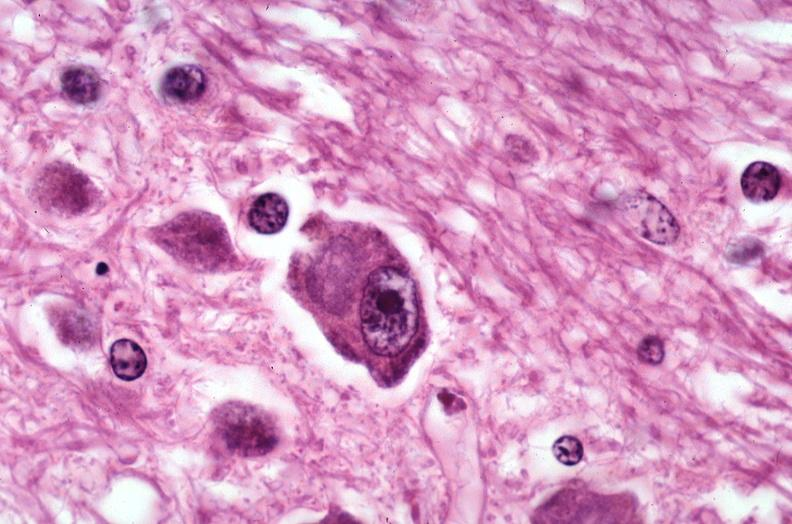where is this?
Answer the question using a single word or phrase. Nervous 